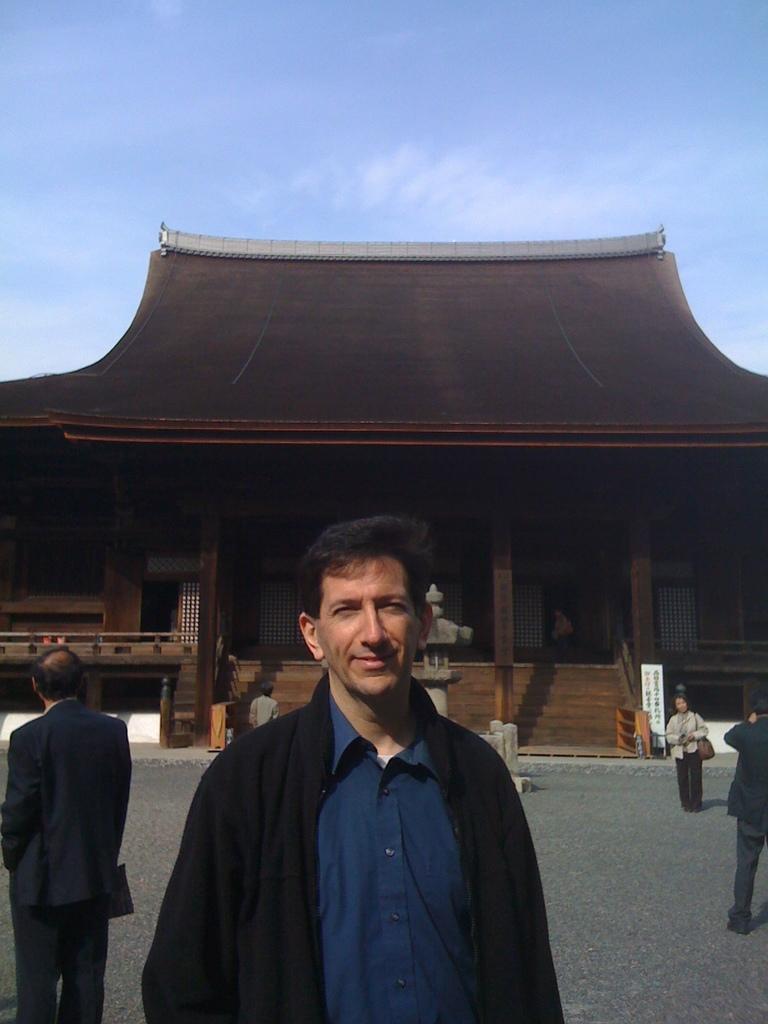How would you summarize this image in a sentence or two? A man is standing wearing blue shirt and black coat. There are other people. There is a brown building at the back which has fence and pillars. 